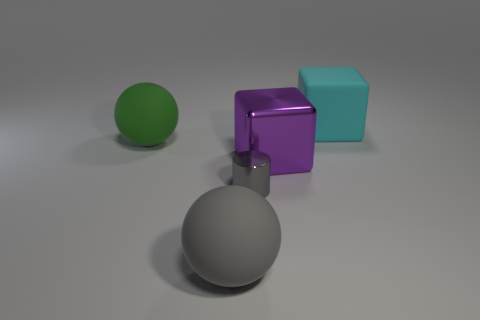Add 2 matte balls. How many objects exist? 7 Subtract all spheres. How many objects are left? 3 Subtract 1 gray spheres. How many objects are left? 4 Subtract all cyan cubes. Subtract all cylinders. How many objects are left? 3 Add 5 green things. How many green things are left? 6 Add 1 cyan things. How many cyan things exist? 2 